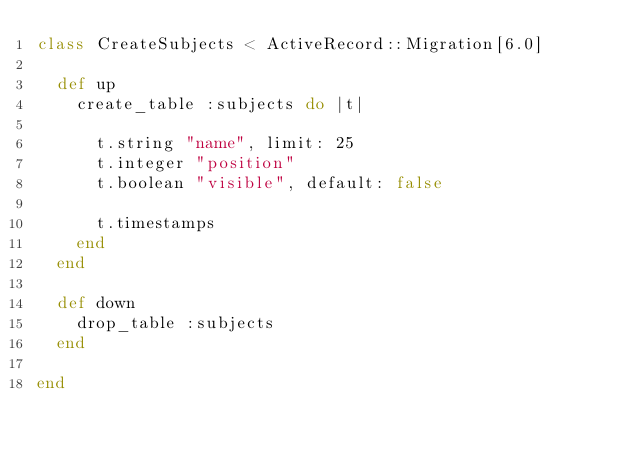Convert code to text. <code><loc_0><loc_0><loc_500><loc_500><_Ruby_>class CreateSubjects < ActiveRecord::Migration[6.0]
  
  def up
    create_table :subjects do |t|

      t.string "name", limit: 25
      t.integer "position"
      t.boolean "visible", default: false

      t.timestamps
    end
  end

  def down
    drop_table :subjects
  end

end
</code> 